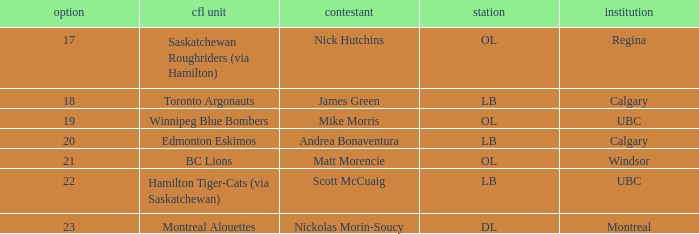What place is the player who traveled to regina in? OL. 